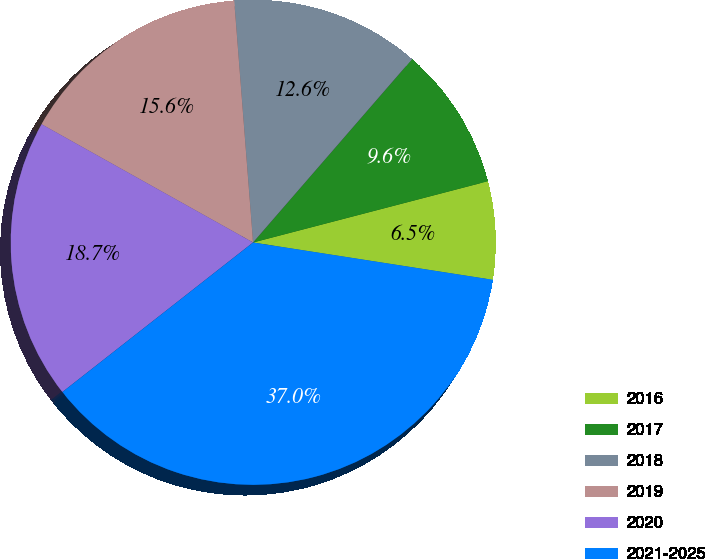<chart> <loc_0><loc_0><loc_500><loc_500><pie_chart><fcel>2016<fcel>2017<fcel>2018<fcel>2019<fcel>2020<fcel>2021-2025<nl><fcel>6.52%<fcel>9.57%<fcel>12.61%<fcel>15.65%<fcel>18.7%<fcel>36.96%<nl></chart> 